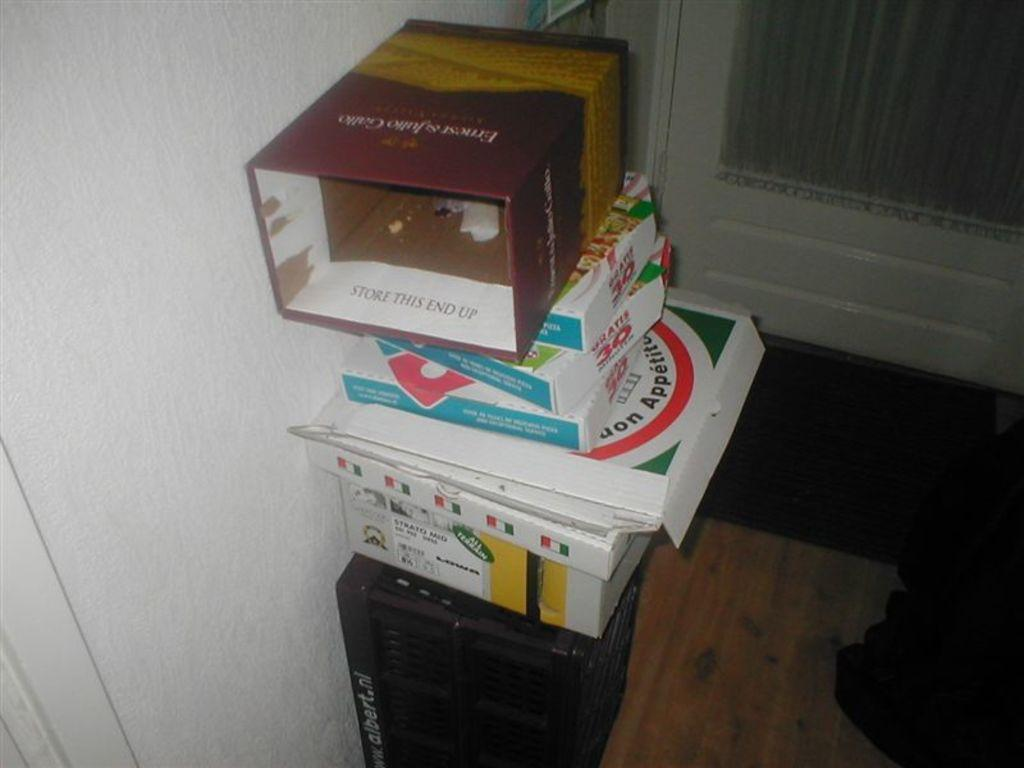Provide a one-sentence caption for the provided image. A pile of boxes with the one at the bottom reading albert.nl. 